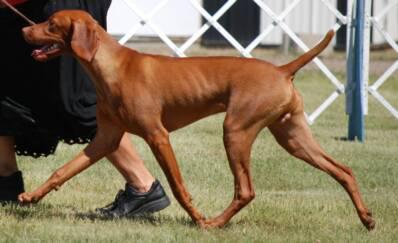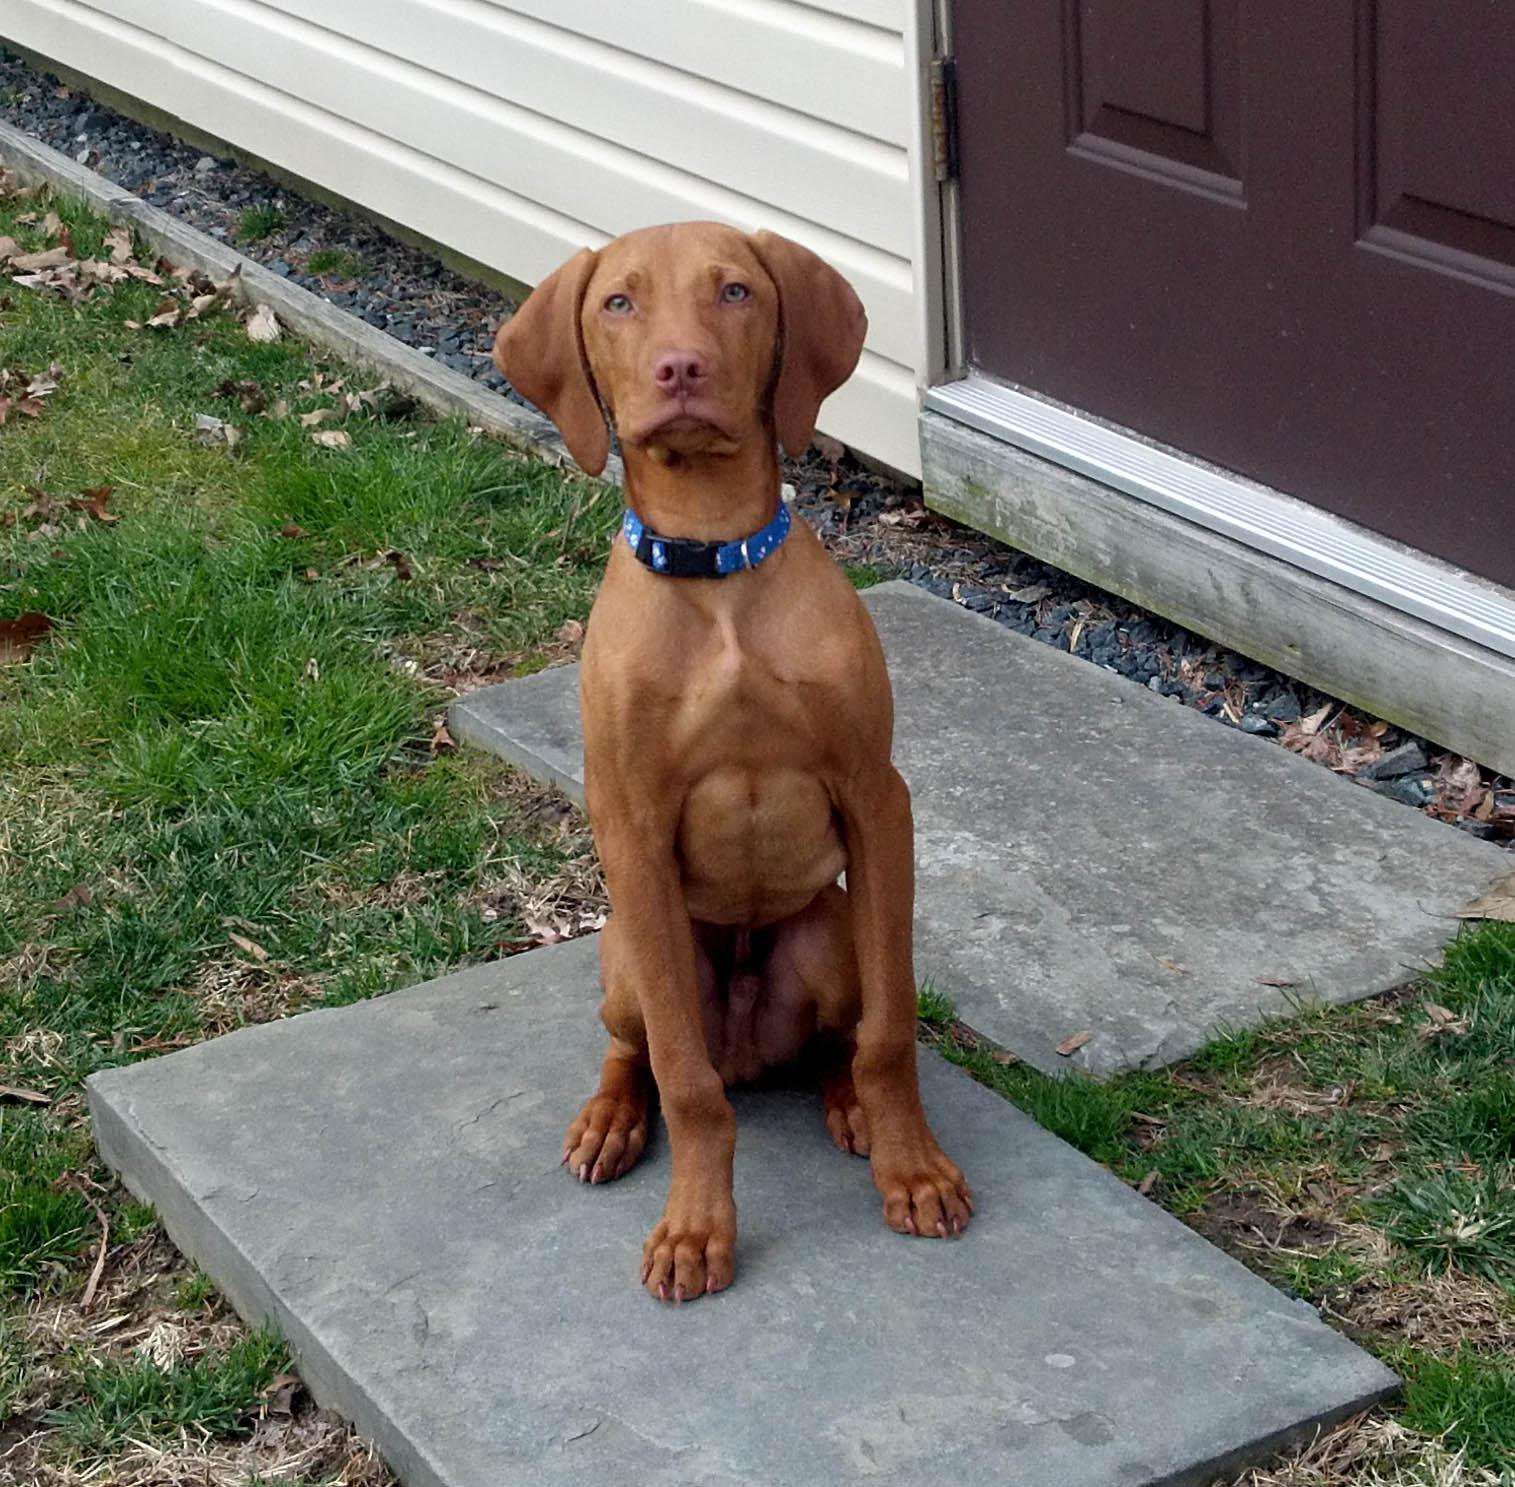The first image is the image on the left, the second image is the image on the right. For the images shown, is this caption "The right image shows a person in blue jeans kneeling behind a leftward-facing dog standing in profile, with one hand on the dog's chin and the other hand on its tail." true? Answer yes or no. No. The first image is the image on the left, the second image is the image on the right. For the images displayed, is the sentence "IN at least one image there is a collared dog sitting straight forward." factually correct? Answer yes or no. Yes. 